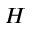Convert formula to latex. <formula><loc_0><loc_0><loc_500><loc_500>H</formula> 